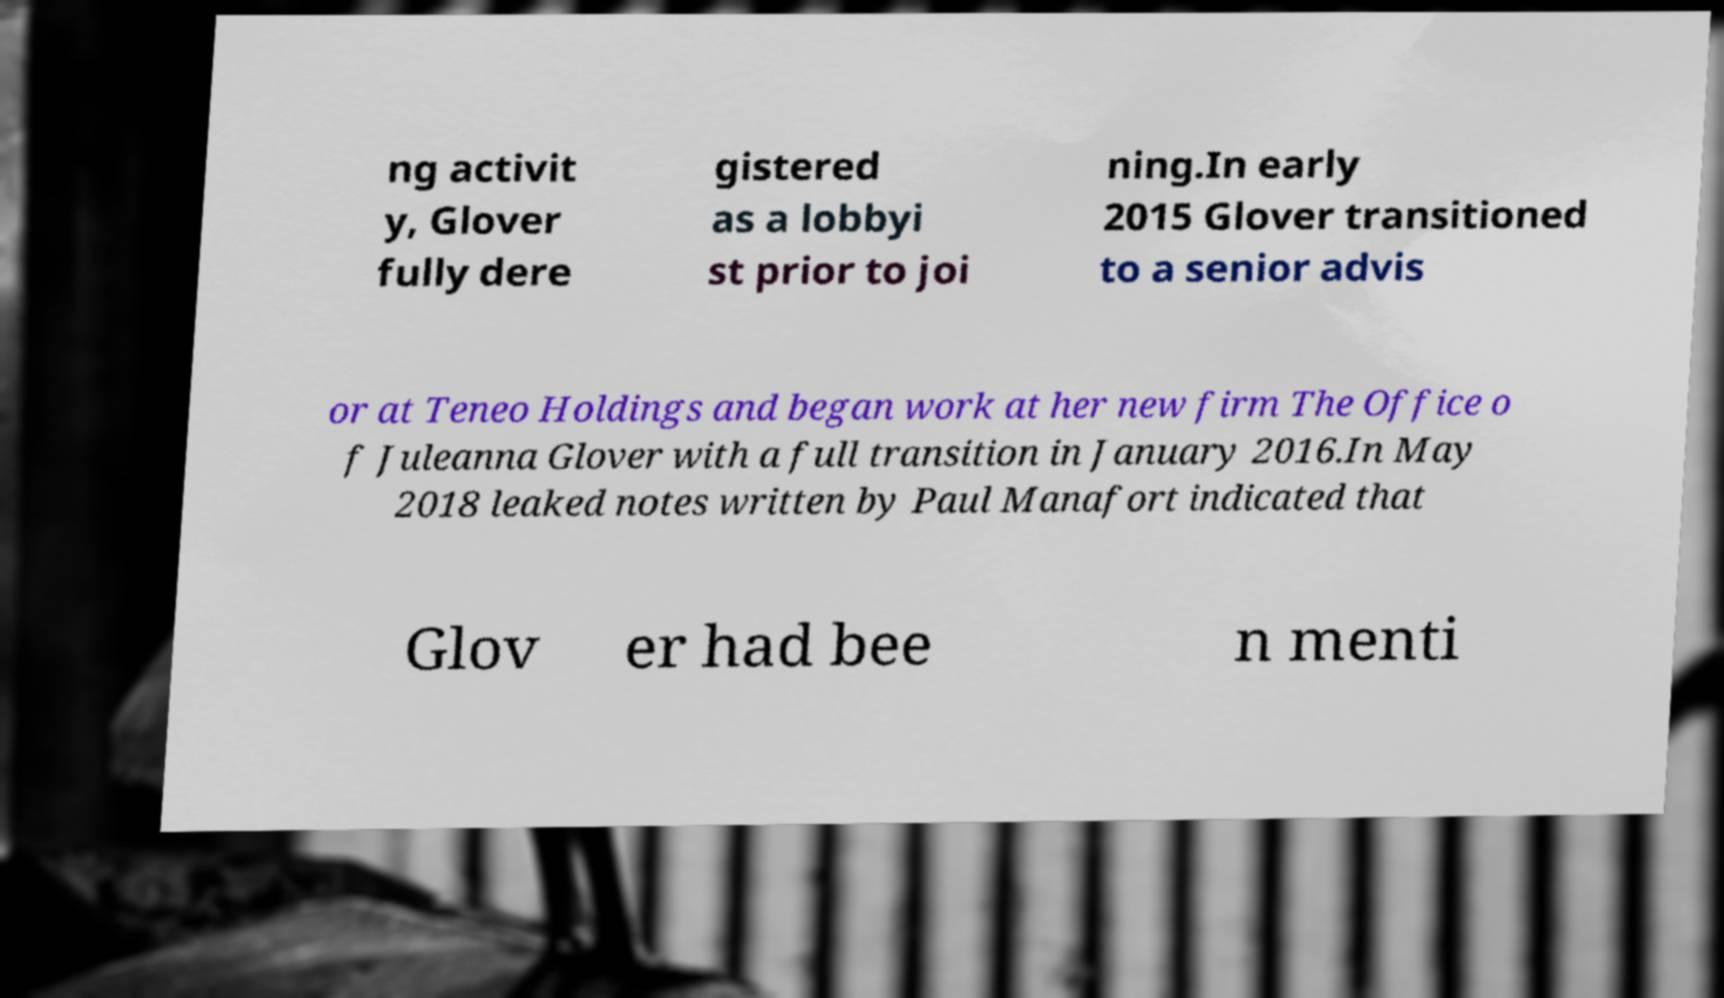There's text embedded in this image that I need extracted. Can you transcribe it verbatim? ng activit y, Glover fully dere gistered as a lobbyi st prior to joi ning.In early 2015 Glover transitioned to a senior advis or at Teneo Holdings and began work at her new firm The Office o f Juleanna Glover with a full transition in January 2016.In May 2018 leaked notes written by Paul Manafort indicated that Glov er had bee n menti 